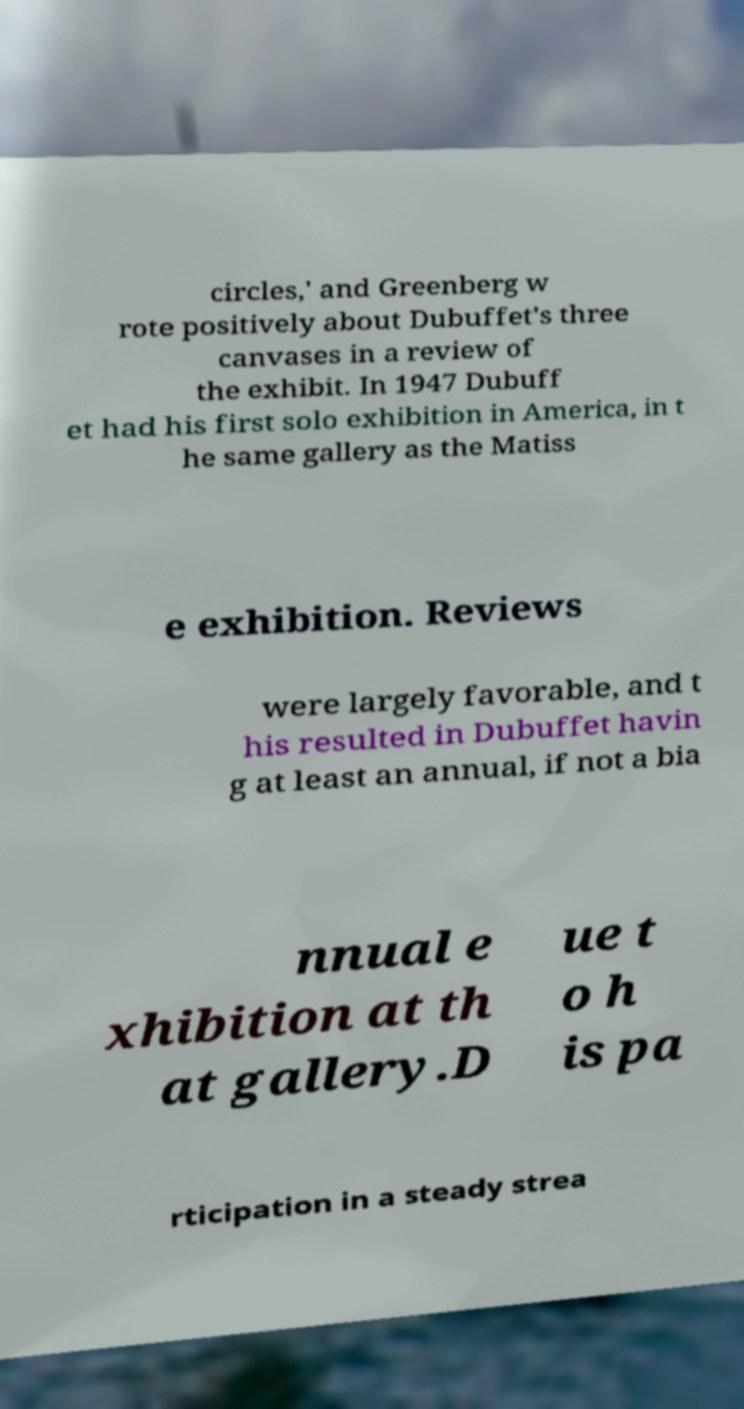For documentation purposes, I need the text within this image transcribed. Could you provide that? circles,' and Greenberg w rote positively about Dubuffet's three canvases in a review of the exhibit. In 1947 Dubuff et had his first solo exhibition in America, in t he same gallery as the Matiss e exhibition. Reviews were largely favorable, and t his resulted in Dubuffet havin g at least an annual, if not a bia nnual e xhibition at th at gallery.D ue t o h is pa rticipation in a steady strea 